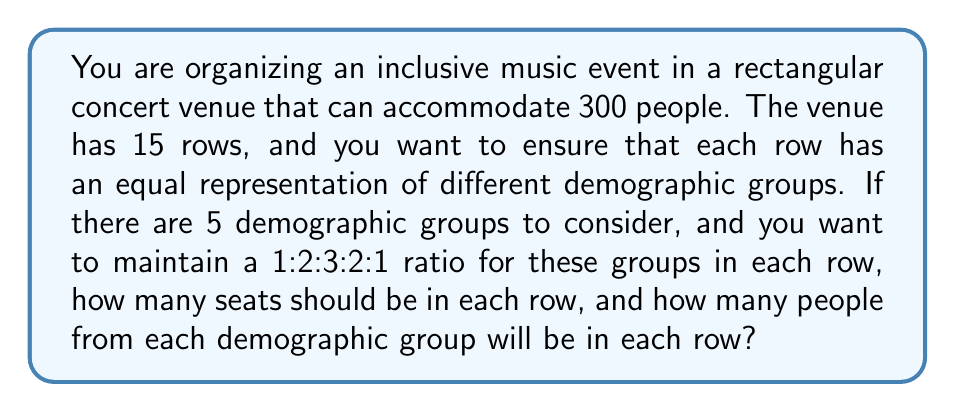Help me with this question. Let's approach this problem step by step:

1. First, we need to determine the number of seats per row:
   Total seats = 300
   Number of rows = 15
   Seats per row = 300 ÷ 15 = 20

2. Now, we need to distribute these 20 seats according to the given ratio of 1:2:3:2:1 for the five demographic groups.

3. Let's define a unit of this ratio:
   1 + 2 + 3 + 2 + 1 = 9 units

4. We need to find how many seats each unit represents:
   Seats per unit = 20 ÷ 9 ≈ 2.22 (rounded to 2 decimal places)

5. Now, we can calculate the number of seats for each group in a row:
   Group 1: 1 × 2.22 ≈ 2.22 seats
   Group 2: 2 × 2.22 ≈ 4.44 seats
   Group 3: 3 × 2.22 ≈ 6.67 seats
   Group 4: 2 × 2.22 ≈ 4.44 seats
   Group 5: 1 × 2.22 ≈ 2.22 seats

6. Since we can't have fractional seats, we need to round these numbers. The best way to maintain the ratio and ensure we have exactly 20 seats is:
   Group 1: 2 seats
   Group 2: 4 seats
   Group 3: 7 seats
   Group 4: 4 seats
   Group 5: 3 seats

   Total: 2 + 4 + 7 + 4 + 3 = 20 seats

This distribution closely maintains the original ratio while ensuring a whole number of seats for each group and exactly 20 seats per row.
Answer: Each row should have 20 seats. The distribution of demographic groups in each row should be:
Group 1: 2 people
Group 2: 4 people
Group 3: 7 people
Group 4: 4 people
Group 5: 3 people 